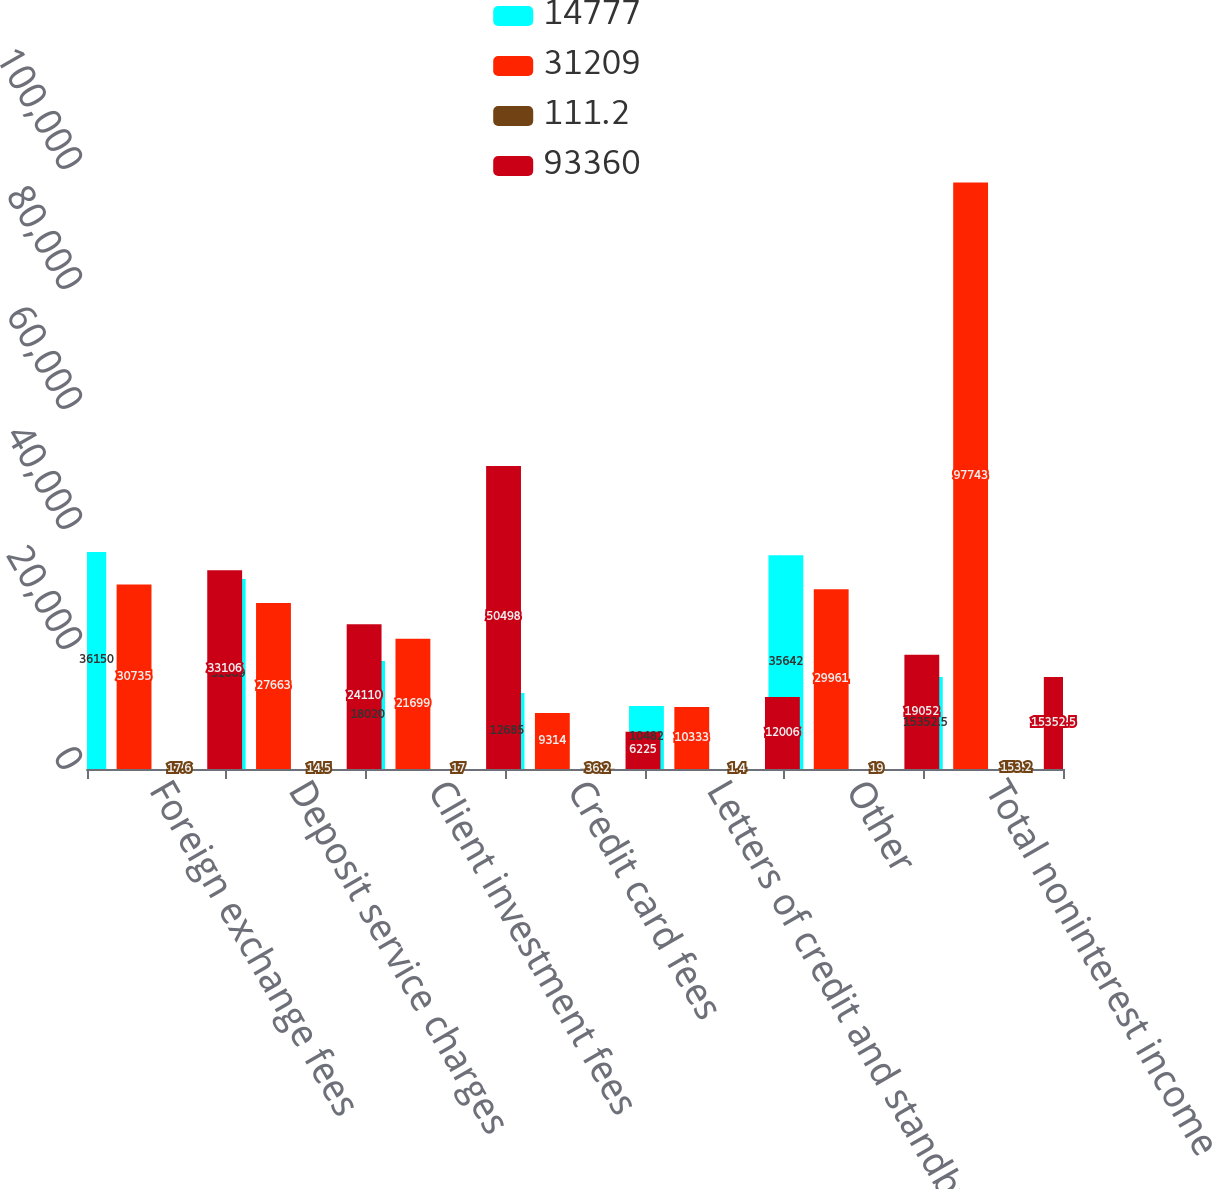Convert chart. <chart><loc_0><loc_0><loc_500><loc_500><stacked_bar_chart><ecel><fcel>Foreign exchange fees<fcel>Deposit service charges<fcel>Client investment fees<fcel>Credit card fees<fcel>Letters of credit and standby<fcel>Other<fcel>Total noninterest income<nl><fcel>14777<fcel>36150<fcel>31669<fcel>18020<fcel>12685<fcel>10482<fcel>35642<fcel>15352.5<nl><fcel>31209<fcel>30735<fcel>27663<fcel>21699<fcel>9314<fcel>10333<fcel>29961<fcel>97743<nl><fcel>111.2<fcel>17.6<fcel>14.5<fcel>17<fcel>36.2<fcel>1.4<fcel>19<fcel>153.2<nl><fcel>93360<fcel>33106<fcel>24110<fcel>50498<fcel>6225<fcel>12006<fcel>19052<fcel>15352.5<nl></chart> 